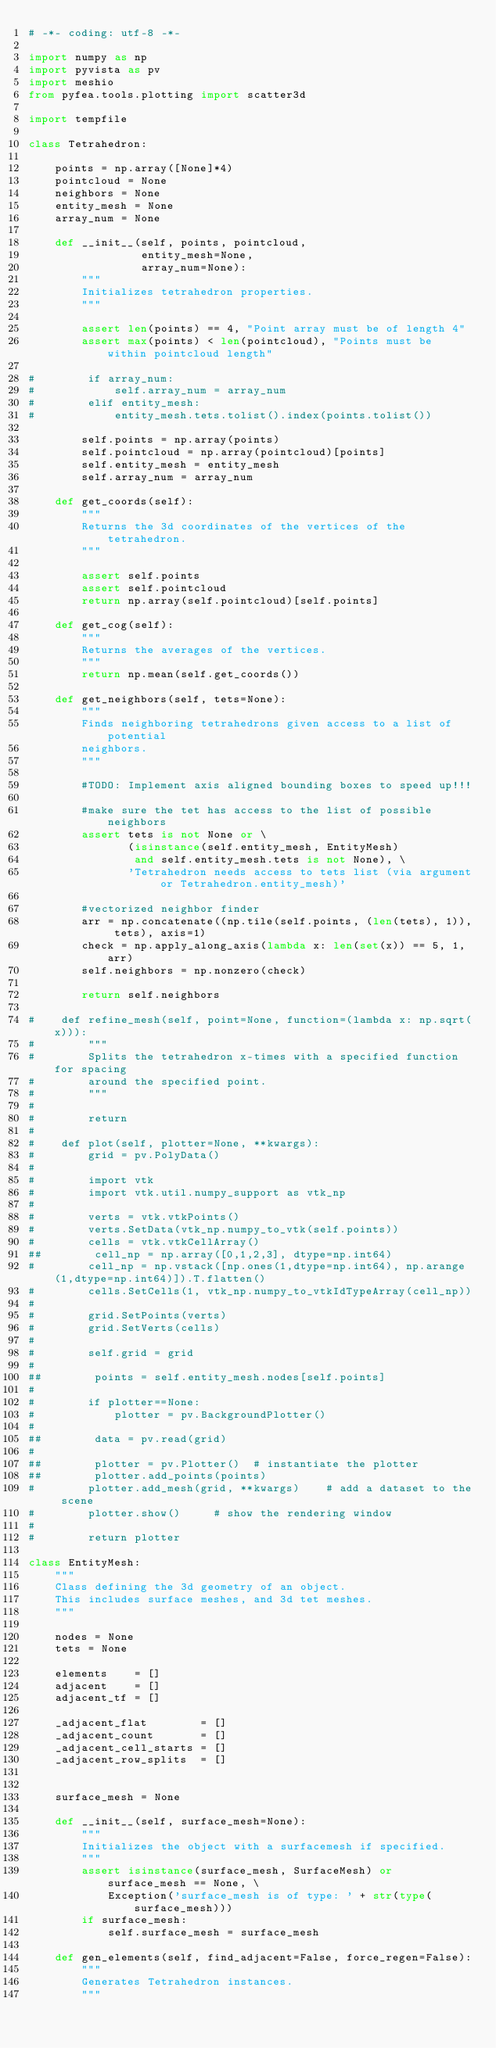Convert code to text. <code><loc_0><loc_0><loc_500><loc_500><_Python_># -*- coding: utf-8 -*-

import numpy as np
import pyvista as pv
import meshio
from pyfea.tools.plotting import scatter3d

import tempfile

class Tetrahedron:
    
    points = np.array([None]*4)
    pointcloud = None
    neighbors = None
    entity_mesh = None
    array_num = None
    
    def __init__(self, points, pointcloud,
                 entity_mesh=None,
                 array_num=None):
        """
        Initializes tetrahedron properties.
        """
        
        assert len(points) == 4, "Point array must be of length 4"
        assert max(points) < len(pointcloud), "Points must be within pointcloud length"
        
#        if array_num:
#            self.array_num = array_num
#        elif entity_mesh:
#            entity_mesh.tets.tolist().index(points.tolist())
        
        self.points = np.array(points)
        self.pointcloud = np.array(pointcloud)[points]
        self.entity_mesh = entity_mesh
        self.array_num = array_num
        
    def get_coords(self):
        """
        Returns the 3d coordinates of the vertices of the tetrahedron.
        """
        
        assert self.points
        assert self.pointcloud
        return np.array(self.pointcloud)[self.points]
        
    def get_cog(self):
        """
        Returns the averages of the vertices.
        """
        return np.mean(self.get_coords())
    
    def get_neighbors(self, tets=None):
        """
        Finds neighboring tetrahedrons given access to a list of potential
        neighbors.
        """
        
        #TODO: Implement axis aligned bounding boxes to speed up!!!
        
        #make sure the tet has access to the list of possible neighbors
        assert tets is not None or \
               (isinstance(self.entity_mesh, EntityMesh)
                and self.entity_mesh.tets is not None), \
               'Tetrahedron needs access to tets list (via argument or Tetrahedron.entity_mesh)'
               
        #vectorized neighbor finder
        arr = np.concatenate((np.tile(self.points, (len(tets), 1)), tets), axis=1)
        check = np.apply_along_axis(lambda x: len(set(x)) == 5, 1, arr)
        self.neighbors = np.nonzero(check)
        
        return self.neighbors
    
#    def refine_mesh(self, point=None, function=(lambda x: np.sqrt(x))):
#        """
#        Splits the tetrahedron x-times with a specified function for spacing
#        around the specified point.
#        """
#    
#        return
#    
#    def plot(self, plotter=None, **kwargs):
#        grid = pv.PolyData()
#        
#        import vtk
#        import vtk.util.numpy_support as vtk_np
#        
#        verts = vtk.vtkPoints()
#        verts.SetData(vtk_np.numpy_to_vtk(self.points))
#        cells = vtk.vtkCellArray()
##        cell_np = np.array([0,1,2,3], dtype=np.int64)
#        cell_np = np.vstack([np.ones(1,dtype=np.int64), np.arange(1,dtype=np.int64)]).T.flatten()
#        cells.SetCells(1, vtk_np.numpy_to_vtkIdTypeArray(cell_np))
#        
#        grid.SetPoints(verts)
#        grid.SetVerts(cells)
#        
#        self.grid = grid
#        
##        points = self.entity_mesh.nodes[self.points]
#        
#        if plotter==None:
#            plotter = pv.BackgroundPlotter()
#        
##        data = pv.read(grid)
#        
##        plotter = pv.Plotter()  # instantiate the plotter
##        plotter.add_points(points)
#        plotter.add_mesh(grid, **kwargs)    # add a dataset to the scene
#        plotter.show()     # show the rendering window
#        
#        return plotter
    
class EntityMesh:
    """
    Class defining the 3d geometry of an object.
    This includes surface meshes, and 3d tet meshes.
    """
    
    nodes = None
    tets = None
    
    elements    = []
    adjacent    = []
    adjacent_tf = []
    
    _adjacent_flat        = []
    _adjacent_count       = []
    _adjacent_cell_starts = []
    _adjacent_row_splits  = []
                
    
    surface_mesh = None
    
    def __init__(self, surface_mesh=None):
        """
        Initializes the object with a surfacemesh if specified.
        """
        assert isinstance(surface_mesh, SurfaceMesh) or surface_mesh == None, \
            Exception('surface_mesh is of type: ' + str(type(surface_mesh)))
        if surface_mesh:
            self.surface_mesh = surface_mesh
        
    def gen_elements(self, find_adjacent=False, force_regen=False):
        """
        Generates Tetrahedron instances.
        """
        </code> 